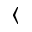Convert formula to latex. <formula><loc_0><loc_0><loc_500><loc_500>\langle</formula> 